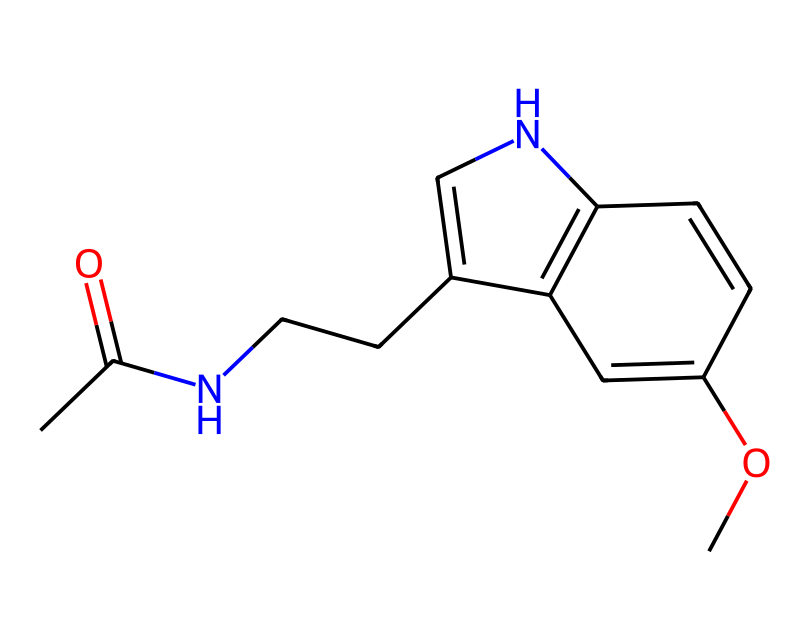What is the molecular formula of melatonin? To determine the molecular formula, we need to count the types and numbers of each atom present in the SMILES representation. Looking closely, we identify carbon (C), hydrogen (H), nitrogen (N), and oxygen (O) atoms. The counts are as follows: 13 carbon atoms, 16 hydrogen atoms, 2 nitrogen atoms, and 1 oxygen atom, leading to the molecular formula C13H16N2O.
Answer: C13H16N2O How many nitrogen atoms are present in melatonin? In the SMILES representation, there are two nitrogen symbols (N), indicating that there are two nitrogen atoms in the molecule.
Answer: 2 What type of functional groups are present in melatonin? The presence of the acetyl (CC(=O)) and methoxy (OC) groups identifies the functional groups. The acetyl group contributes to the molecule's properties, and the methoxy group is indicated by the -O- attachment to a carbon ring.
Answer: acetyl and methoxy Does melatonin contain a ring structure? When examining the SMILES structure, there is a cyclic component where the carbon and nitrogen atoms are connected in a loop, confirming the presence of a ring structure in melatonin.
Answer: Yes What is the primary biological role of melatonin? Melatonin is primarily involved in the regulation of sleep-wake cycles in the human body, signaling the onset of sleep during the night. Its function as a hormone is crucial for circadian rhythms.
Answer: Regulation of sleep Which atom(s) in melatonin contribute to its ability to interact with receptors? The nitrogen atoms in the structure play a critical role in interacting with melatonin receptors, as they are essential for forming hydrogen bonds and other interactions with biological targets.
Answer: Nitrogen atoms How does the structure of melatonin relate to its solubility? The presence of polar groups such as the methoxy (-O-) and acetyl (C=O) contributes to its overall polarity, enhancing solubility in polar solvents like water, while the carbon rings contribute to its lipophilicity.
Answer: Enhances solubility 